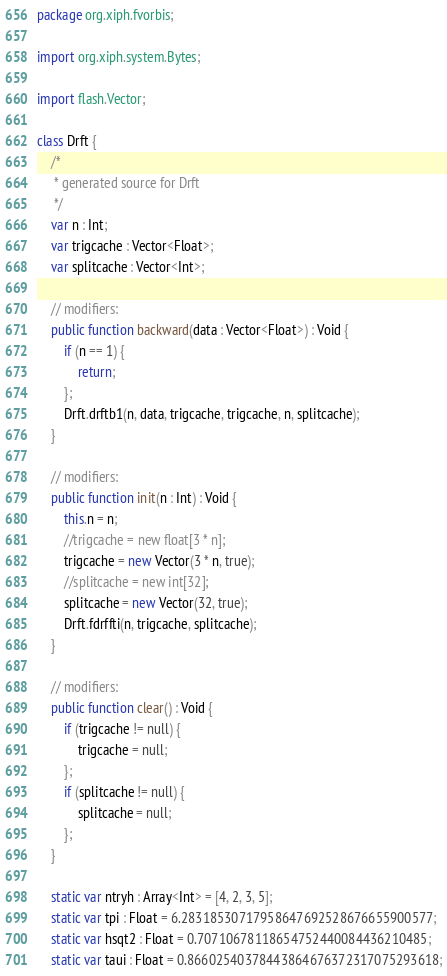<code> <loc_0><loc_0><loc_500><loc_500><_Haxe_>package org.xiph.fvorbis;

import org.xiph.system.Bytes;

import flash.Vector;

class Drft {
    /*
     * generated source for Drft
     */
    var n : Int;
    var trigcache : Vector<Float>;
    var splitcache : Vector<Int>;

    // modifiers: 
    public function backward(data : Vector<Float>) : Void {
        if (n == 1) {
            return;
        };
        Drft.drftb1(n, data, trigcache, trigcache, n, splitcache);
    }

    // modifiers: 
    public function init(n : Int) : Void {
        this.n = n;
        //trigcache = new float[3 * n];
        trigcache = new Vector(3 * n, true);
        //splitcache = new int[32];
        splitcache = new Vector(32, true);
        Drft.fdrffti(n, trigcache, splitcache);
    }

    // modifiers: 
    public function clear() : Void {
        if (trigcache != null) {
            trigcache = null;
        };
        if (splitcache != null) {
            splitcache = null;
        };
    }

    static var ntryh : Array<Int> = [4, 2, 3, 5];
    static var tpi : Float = 6.28318530717958647692528676655900577;
    static var hsqt2 : Float = 0.70710678118654752440084436210485;
    static var taui : Float = 0.86602540378443864676372317075293618;</code> 